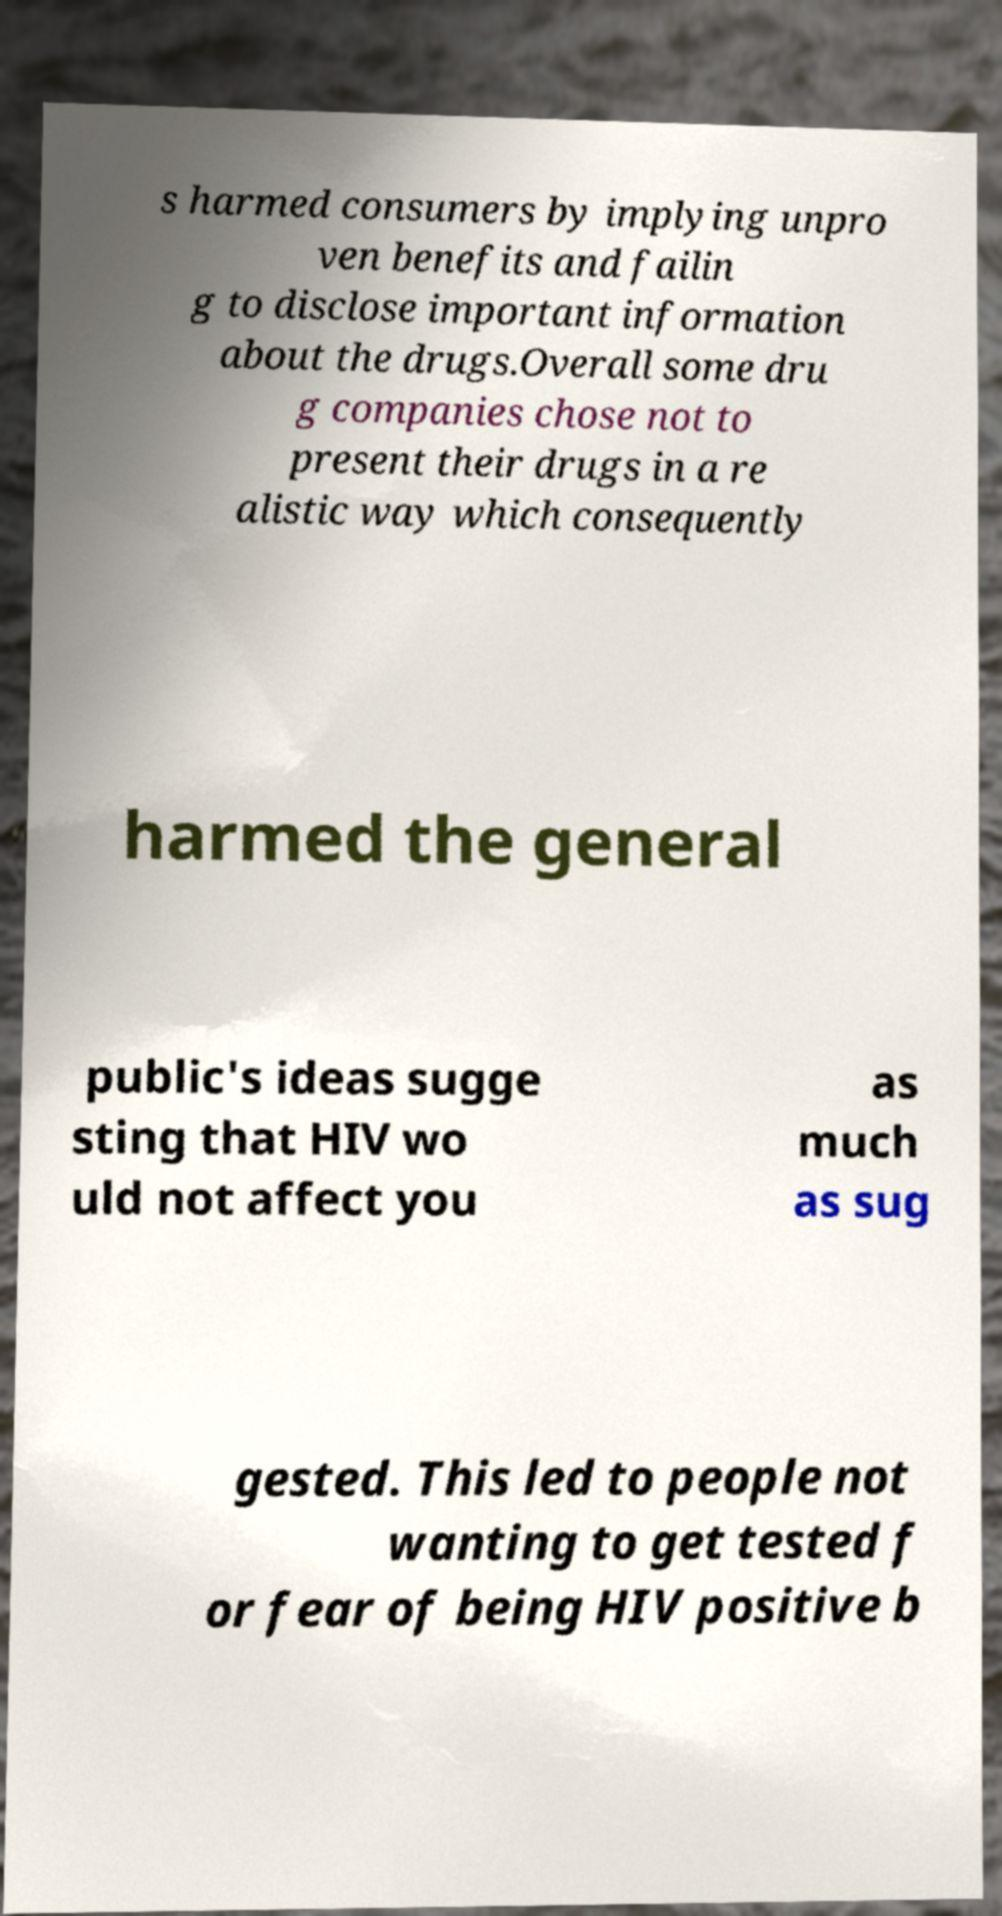Can you read and provide the text displayed in the image?This photo seems to have some interesting text. Can you extract and type it out for me? s harmed consumers by implying unpro ven benefits and failin g to disclose important information about the drugs.Overall some dru g companies chose not to present their drugs in a re alistic way which consequently harmed the general public's ideas sugge sting that HIV wo uld not affect you as much as sug gested. This led to people not wanting to get tested f or fear of being HIV positive b 